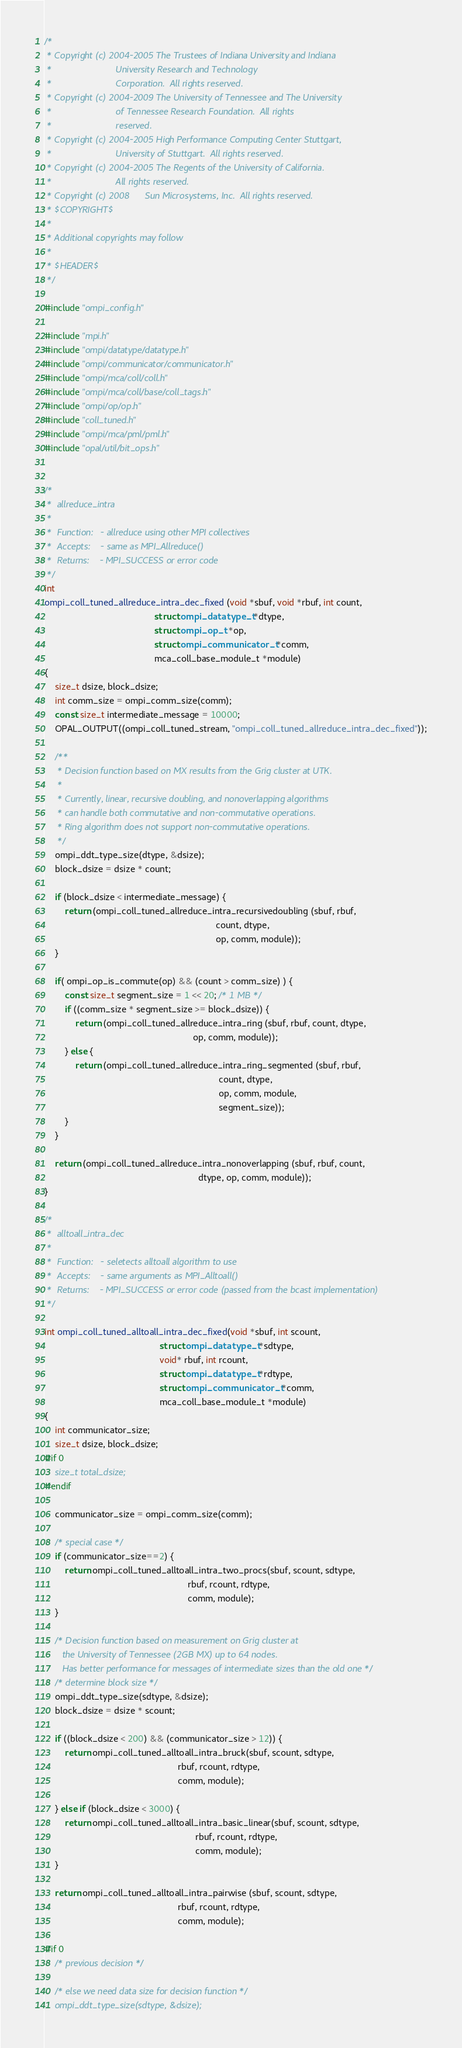Convert code to text. <code><loc_0><loc_0><loc_500><loc_500><_C_>/*
 * Copyright (c) 2004-2005 The Trustees of Indiana University and Indiana
 *                         University Research and Technology
 *                         Corporation.  All rights reserved.
 * Copyright (c) 2004-2009 The University of Tennessee and The University
 *                         of Tennessee Research Foundation.  All rights
 *                         reserved.
 * Copyright (c) 2004-2005 High Performance Computing Center Stuttgart, 
 *                         University of Stuttgart.  All rights reserved.
 * Copyright (c) 2004-2005 The Regents of the University of California.
 *                         All rights reserved.
 * Copyright (c) 2008      Sun Microsystems, Inc.  All rights reserved.
 * $COPYRIGHT$
 * 
 * Additional copyrights may follow
 * 
 * $HEADER$
 */

#include "ompi_config.h"

#include "mpi.h"
#include "ompi/datatype/datatype.h"
#include "ompi/communicator/communicator.h"
#include "ompi/mca/coll/coll.h"
#include "ompi/mca/coll/base/coll_tags.h"
#include "ompi/op/op.h"
#include "coll_tuned.h"
#include "ompi/mca/pml/pml.h"
#include "opal/util/bit_ops.h"


/*
 *  allreduce_intra
 *
 *  Function:   - allreduce using other MPI collectives
 *  Accepts:    - same as MPI_Allreduce()
 *  Returns:    - MPI_SUCCESS or error code
 */
int
ompi_coll_tuned_allreduce_intra_dec_fixed (void *sbuf, void *rbuf, int count,
                                           struct ompi_datatype_t *dtype,
                                           struct ompi_op_t *op,
                                           struct ompi_communicator_t *comm,
                                           mca_coll_base_module_t *module)
{
    size_t dsize, block_dsize;
    int comm_size = ompi_comm_size(comm);
    const size_t intermediate_message = 10000;
    OPAL_OUTPUT((ompi_coll_tuned_stream, "ompi_coll_tuned_allreduce_intra_dec_fixed"));

    /**
     * Decision function based on MX results from the Grig cluster at UTK.
     * 
     * Currently, linear, recursive doubling, and nonoverlapping algorithms 
     * can handle both commutative and non-commutative operations.
     * Ring algorithm does not support non-commutative operations.
     */
    ompi_ddt_type_size(dtype, &dsize);
    block_dsize = dsize * count;

    if (block_dsize < intermediate_message) {
        return (ompi_coll_tuned_allreduce_intra_recursivedoubling (sbuf, rbuf, 
                                                                   count, dtype,
                                                                   op, comm, module));
    } 

    if( ompi_op_is_commute(op) && (count > comm_size) ) {
        const size_t segment_size = 1 << 20; /* 1 MB */
        if ((comm_size * segment_size >= block_dsize)) {
            return (ompi_coll_tuned_allreduce_intra_ring (sbuf, rbuf, count, dtype, 
                                                          op, comm, module));
        } else {
            return (ompi_coll_tuned_allreduce_intra_ring_segmented (sbuf, rbuf, 
                                                                    count, dtype, 
                                                                    op, comm, module,
                                                                    segment_size));
        }
    }

    return (ompi_coll_tuned_allreduce_intra_nonoverlapping (sbuf, rbuf, count, 
                                                            dtype, op, comm, module));
}

/*
 *	alltoall_intra_dec 
 *
 *	Function:	- seletects alltoall algorithm to use
 *	Accepts:	- same arguments as MPI_Alltoall()
 *	Returns:	- MPI_SUCCESS or error code (passed from the bcast implementation)
 */

int ompi_coll_tuned_alltoall_intra_dec_fixed(void *sbuf, int scount, 
                                             struct ompi_datatype_t *sdtype,
                                             void* rbuf, int rcount, 
                                             struct ompi_datatype_t *rdtype, 
                                             struct ompi_communicator_t *comm,
                                             mca_coll_base_module_t *module)
{
    int communicator_size;
    size_t dsize, block_dsize;
#if 0
    size_t total_dsize;
#endif

    communicator_size = ompi_comm_size(comm);

    /* special case */
    if (communicator_size==2) {
        return ompi_coll_tuned_alltoall_intra_two_procs(sbuf, scount, sdtype, 
                                                        rbuf, rcount, rdtype, 
                                                        comm, module);
    }

    /* Decision function based on measurement on Grig cluster at 
       the University of Tennessee (2GB MX) up to 64 nodes.
       Has better performance for messages of intermediate sizes than the old one */
    /* determine block size */
    ompi_ddt_type_size(sdtype, &dsize);
    block_dsize = dsize * scount;

    if ((block_dsize < 200) && (communicator_size > 12)) {
        return ompi_coll_tuned_alltoall_intra_bruck(sbuf, scount, sdtype, 
                                                    rbuf, rcount, rdtype,
                                                    comm, module);

    } else if (block_dsize < 3000) {
        return ompi_coll_tuned_alltoall_intra_basic_linear(sbuf, scount, sdtype, 
                                                           rbuf, rcount, rdtype, 
                                                           comm, module);
    }

    return ompi_coll_tuned_alltoall_intra_pairwise (sbuf, scount, sdtype, 
                                                    rbuf, rcount, rdtype,
                                                    comm, module);

#if 0
    /* previous decision */

    /* else we need data size for decision function */
    ompi_ddt_type_size(sdtype, &dsize);</code> 